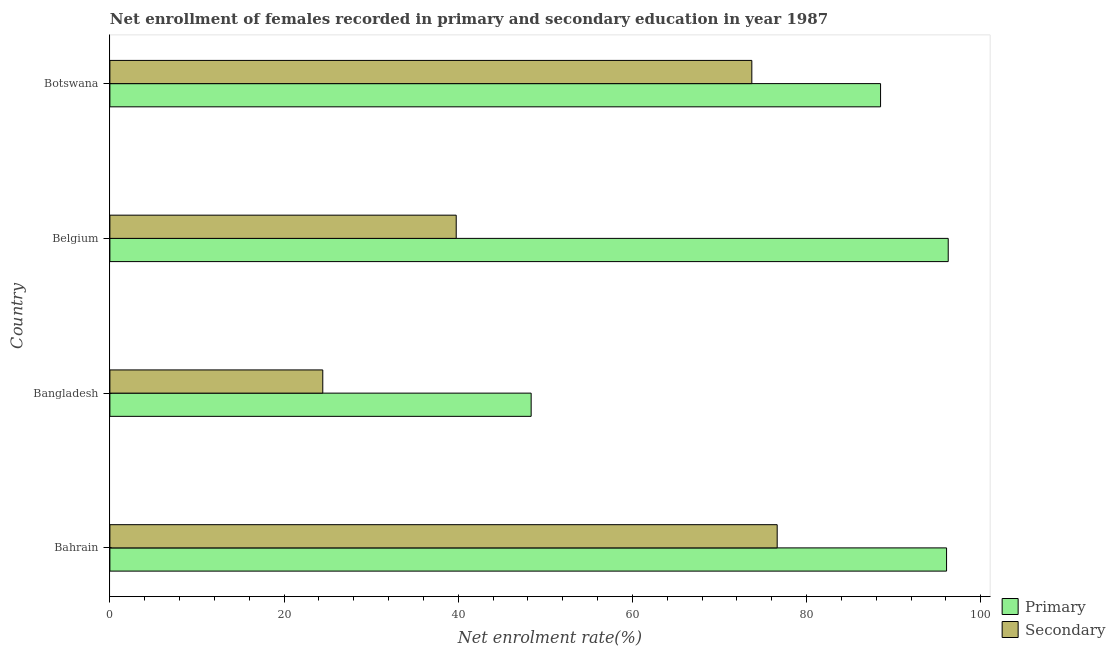How many groups of bars are there?
Your response must be concise. 4. Are the number of bars on each tick of the Y-axis equal?
Give a very brief answer. Yes. How many bars are there on the 2nd tick from the top?
Keep it short and to the point. 2. How many bars are there on the 3rd tick from the bottom?
Keep it short and to the point. 2. What is the label of the 4th group of bars from the top?
Keep it short and to the point. Bahrain. What is the enrollment rate in secondary education in Bangladesh?
Ensure brevity in your answer.  24.45. Across all countries, what is the maximum enrollment rate in secondary education?
Keep it short and to the point. 76.63. Across all countries, what is the minimum enrollment rate in secondary education?
Keep it short and to the point. 24.45. In which country was the enrollment rate in secondary education maximum?
Provide a short and direct response. Bahrain. What is the total enrollment rate in primary education in the graph?
Keep it short and to the point. 329.22. What is the difference between the enrollment rate in primary education in Belgium and that in Botswana?
Ensure brevity in your answer.  7.77. What is the difference between the enrollment rate in primary education in Bangladesh and the enrollment rate in secondary education in Bahrain?
Provide a short and direct response. -28.25. What is the average enrollment rate in secondary education per country?
Your answer should be compact. 53.64. What is the difference between the enrollment rate in primary education and enrollment rate in secondary education in Bahrain?
Your answer should be compact. 19.45. In how many countries, is the enrollment rate in primary education greater than 60 %?
Make the answer very short. 3. What is the ratio of the enrollment rate in secondary education in Bahrain to that in Bangladesh?
Provide a succinct answer. 3.13. Is the enrollment rate in secondary education in Belgium less than that in Botswana?
Provide a short and direct response. Yes. What is the difference between the highest and the second highest enrollment rate in primary education?
Make the answer very short. 0.19. What is the difference between the highest and the lowest enrollment rate in secondary education?
Give a very brief answer. 52.18. In how many countries, is the enrollment rate in secondary education greater than the average enrollment rate in secondary education taken over all countries?
Your response must be concise. 2. Is the sum of the enrollment rate in primary education in Bahrain and Bangladesh greater than the maximum enrollment rate in secondary education across all countries?
Provide a succinct answer. Yes. What does the 1st bar from the top in Belgium represents?
Keep it short and to the point. Secondary. What does the 2nd bar from the bottom in Bangladesh represents?
Provide a short and direct response. Secondary. How many countries are there in the graph?
Your answer should be compact. 4. Are the values on the major ticks of X-axis written in scientific E-notation?
Provide a succinct answer. No. Does the graph contain any zero values?
Provide a succinct answer. No. Where does the legend appear in the graph?
Give a very brief answer. Bottom right. How are the legend labels stacked?
Provide a succinct answer. Vertical. What is the title of the graph?
Offer a terse response. Net enrollment of females recorded in primary and secondary education in year 1987. Does "Researchers" appear as one of the legend labels in the graph?
Ensure brevity in your answer.  No. What is the label or title of the X-axis?
Provide a short and direct response. Net enrolment rate(%). What is the Net enrolment rate(%) in Primary in Bahrain?
Provide a short and direct response. 96.08. What is the Net enrolment rate(%) in Secondary in Bahrain?
Ensure brevity in your answer.  76.63. What is the Net enrolment rate(%) in Primary in Bangladesh?
Make the answer very short. 48.38. What is the Net enrolment rate(%) in Secondary in Bangladesh?
Provide a succinct answer. 24.45. What is the Net enrolment rate(%) in Primary in Belgium?
Your answer should be compact. 96.27. What is the Net enrolment rate(%) in Secondary in Belgium?
Offer a very short reply. 39.77. What is the Net enrolment rate(%) of Primary in Botswana?
Keep it short and to the point. 88.5. What is the Net enrolment rate(%) in Secondary in Botswana?
Offer a terse response. 73.72. Across all countries, what is the maximum Net enrolment rate(%) in Primary?
Ensure brevity in your answer.  96.27. Across all countries, what is the maximum Net enrolment rate(%) in Secondary?
Make the answer very short. 76.63. Across all countries, what is the minimum Net enrolment rate(%) in Primary?
Offer a very short reply. 48.38. Across all countries, what is the minimum Net enrolment rate(%) of Secondary?
Offer a terse response. 24.45. What is the total Net enrolment rate(%) in Primary in the graph?
Provide a succinct answer. 329.22. What is the total Net enrolment rate(%) in Secondary in the graph?
Offer a very short reply. 214.56. What is the difference between the Net enrolment rate(%) in Primary in Bahrain and that in Bangladesh?
Keep it short and to the point. 47.7. What is the difference between the Net enrolment rate(%) in Secondary in Bahrain and that in Bangladesh?
Provide a succinct answer. 52.18. What is the difference between the Net enrolment rate(%) in Primary in Bahrain and that in Belgium?
Provide a short and direct response. -0.19. What is the difference between the Net enrolment rate(%) in Secondary in Bahrain and that in Belgium?
Provide a succinct answer. 36.86. What is the difference between the Net enrolment rate(%) in Primary in Bahrain and that in Botswana?
Make the answer very short. 7.58. What is the difference between the Net enrolment rate(%) in Secondary in Bahrain and that in Botswana?
Provide a succinct answer. 2.91. What is the difference between the Net enrolment rate(%) of Primary in Bangladesh and that in Belgium?
Give a very brief answer. -47.89. What is the difference between the Net enrolment rate(%) of Secondary in Bangladesh and that in Belgium?
Offer a very short reply. -15.32. What is the difference between the Net enrolment rate(%) of Primary in Bangladesh and that in Botswana?
Your answer should be very brief. -40.12. What is the difference between the Net enrolment rate(%) of Secondary in Bangladesh and that in Botswana?
Provide a short and direct response. -49.27. What is the difference between the Net enrolment rate(%) in Primary in Belgium and that in Botswana?
Offer a very short reply. 7.77. What is the difference between the Net enrolment rate(%) in Secondary in Belgium and that in Botswana?
Offer a terse response. -33.95. What is the difference between the Net enrolment rate(%) in Primary in Bahrain and the Net enrolment rate(%) in Secondary in Bangladesh?
Provide a succinct answer. 71.63. What is the difference between the Net enrolment rate(%) of Primary in Bahrain and the Net enrolment rate(%) of Secondary in Belgium?
Ensure brevity in your answer.  56.31. What is the difference between the Net enrolment rate(%) of Primary in Bahrain and the Net enrolment rate(%) of Secondary in Botswana?
Keep it short and to the point. 22.36. What is the difference between the Net enrolment rate(%) of Primary in Bangladesh and the Net enrolment rate(%) of Secondary in Belgium?
Your answer should be compact. 8.61. What is the difference between the Net enrolment rate(%) of Primary in Bangladesh and the Net enrolment rate(%) of Secondary in Botswana?
Your response must be concise. -25.34. What is the difference between the Net enrolment rate(%) in Primary in Belgium and the Net enrolment rate(%) in Secondary in Botswana?
Provide a succinct answer. 22.55. What is the average Net enrolment rate(%) in Primary per country?
Offer a terse response. 82.31. What is the average Net enrolment rate(%) in Secondary per country?
Make the answer very short. 53.64. What is the difference between the Net enrolment rate(%) in Primary and Net enrolment rate(%) in Secondary in Bahrain?
Make the answer very short. 19.45. What is the difference between the Net enrolment rate(%) of Primary and Net enrolment rate(%) of Secondary in Bangladesh?
Provide a short and direct response. 23.93. What is the difference between the Net enrolment rate(%) in Primary and Net enrolment rate(%) in Secondary in Belgium?
Make the answer very short. 56.5. What is the difference between the Net enrolment rate(%) of Primary and Net enrolment rate(%) of Secondary in Botswana?
Provide a short and direct response. 14.78. What is the ratio of the Net enrolment rate(%) of Primary in Bahrain to that in Bangladesh?
Give a very brief answer. 1.99. What is the ratio of the Net enrolment rate(%) in Secondary in Bahrain to that in Bangladesh?
Offer a very short reply. 3.13. What is the ratio of the Net enrolment rate(%) in Primary in Bahrain to that in Belgium?
Offer a very short reply. 1. What is the ratio of the Net enrolment rate(%) in Secondary in Bahrain to that in Belgium?
Your response must be concise. 1.93. What is the ratio of the Net enrolment rate(%) in Primary in Bahrain to that in Botswana?
Provide a short and direct response. 1.09. What is the ratio of the Net enrolment rate(%) of Secondary in Bahrain to that in Botswana?
Offer a terse response. 1.04. What is the ratio of the Net enrolment rate(%) in Primary in Bangladesh to that in Belgium?
Offer a very short reply. 0.5. What is the ratio of the Net enrolment rate(%) of Secondary in Bangladesh to that in Belgium?
Provide a short and direct response. 0.61. What is the ratio of the Net enrolment rate(%) of Primary in Bangladesh to that in Botswana?
Your response must be concise. 0.55. What is the ratio of the Net enrolment rate(%) of Secondary in Bangladesh to that in Botswana?
Provide a succinct answer. 0.33. What is the ratio of the Net enrolment rate(%) of Primary in Belgium to that in Botswana?
Your answer should be compact. 1.09. What is the ratio of the Net enrolment rate(%) of Secondary in Belgium to that in Botswana?
Give a very brief answer. 0.54. What is the difference between the highest and the second highest Net enrolment rate(%) of Primary?
Offer a very short reply. 0.19. What is the difference between the highest and the second highest Net enrolment rate(%) of Secondary?
Provide a succinct answer. 2.91. What is the difference between the highest and the lowest Net enrolment rate(%) of Primary?
Provide a short and direct response. 47.89. What is the difference between the highest and the lowest Net enrolment rate(%) in Secondary?
Your answer should be compact. 52.18. 